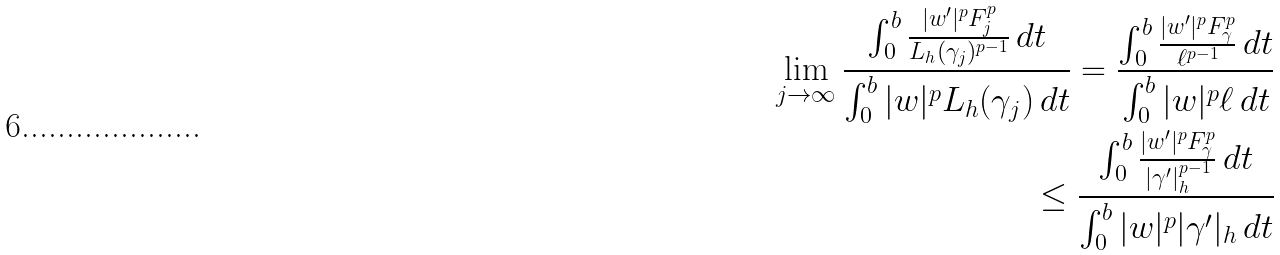Convert formula to latex. <formula><loc_0><loc_0><loc_500><loc_500>\lim _ { j \to \infty } \frac { \int _ { 0 } ^ { b } \frac { | w ^ { \prime } | ^ { p } F _ { j } ^ { p } } { L _ { h } ( \gamma _ { j } ) ^ { p - 1 } } \, d t } { \int _ { 0 } ^ { b } | w | ^ { p } L _ { h } ( \gamma _ { j } ) \, d t } = \frac { \int _ { 0 } ^ { b } \frac { | w ^ { \prime } | ^ { p } F _ { \gamma } ^ { p } } { \ell ^ { p - 1 } } \, d t } { \int _ { 0 } ^ { b } | w | ^ { p } \ell \, d t } \\ \leq \frac { \int _ { 0 } ^ { b } \frac { | w ^ { \prime } | ^ { p } F _ { \gamma } ^ { p } } { | \gamma ^ { \prime } | _ { h } ^ { p - 1 } } \, d t } { \int _ { 0 } ^ { b } | w | ^ { p } | \gamma ^ { \prime } | _ { h } \, d t }</formula> 